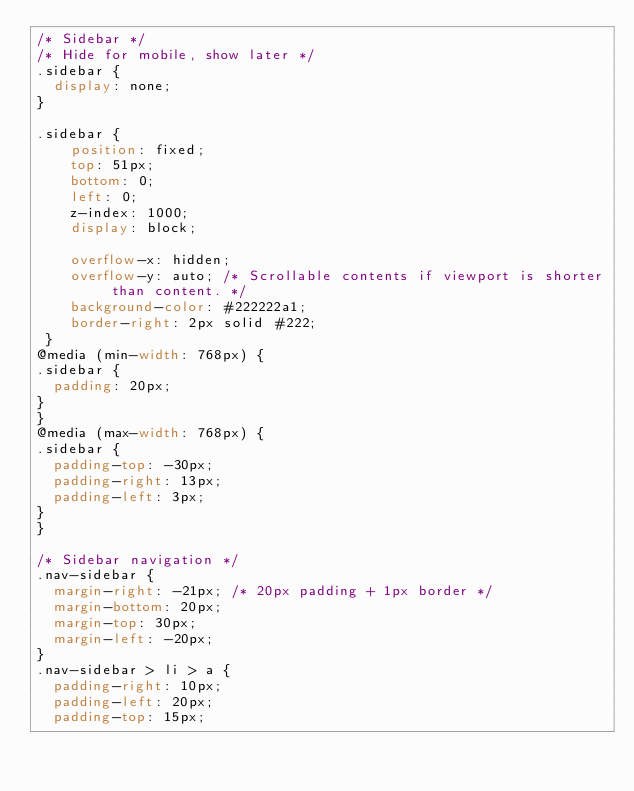Convert code to text. <code><loc_0><loc_0><loc_500><loc_500><_CSS_>/* Sidebar */
/* Hide for mobile, show later */
.sidebar {
  display: none;
}

.sidebar {
    position: fixed;
    top: 51px;
    bottom: 0;
    left: 0;
    z-index: 1000;
    display: block;

    overflow-x: hidden;
    overflow-y: auto; /* Scrollable contents if viewport is shorter than content. */
    background-color: #222222a1;
    border-right: 2px solid #222;
 }
@media (min-width: 768px) {
.sidebar {
	padding: 20px;
}
}
@media (max-width: 768px) {
.sidebar {
	padding-top: -30px;
	padding-right: 13px;
	padding-left: 3px;
}
}

/* Sidebar navigation */
.nav-sidebar {
  margin-right: -21px; /* 20px padding + 1px border */
  margin-bottom: 20px;
  margin-top: 30px;
  margin-left: -20px;
}
.nav-sidebar > li > a {
  padding-right: 10px;
  padding-left: 20px;
  padding-top: 15px;</code> 